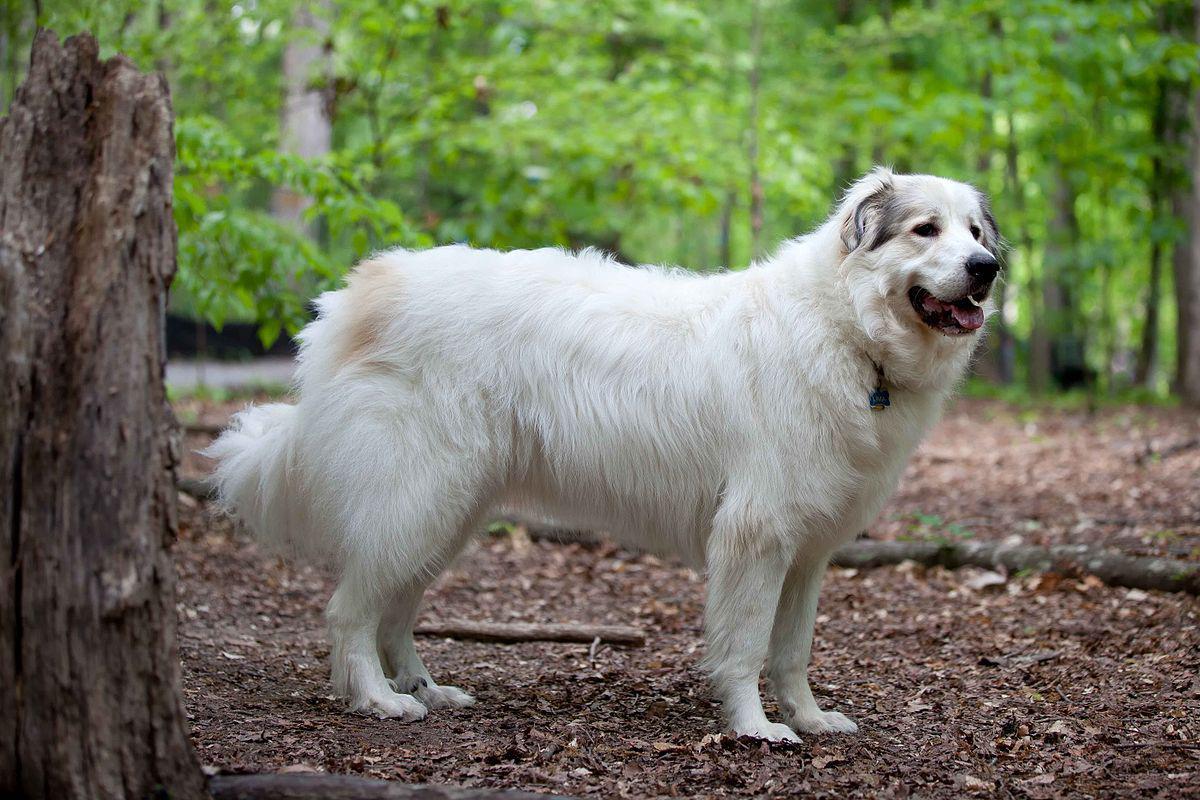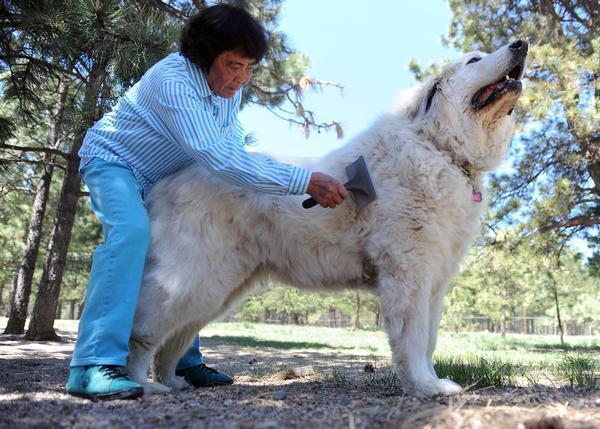The first image is the image on the left, the second image is the image on the right. Analyze the images presented: Is the assertion "There are at least 3 dogs." valid? Answer yes or no. No. The first image is the image on the left, the second image is the image on the right. For the images displayed, is the sentence "Right image shows an older person next to a large dog." factually correct? Answer yes or no. Yes. 